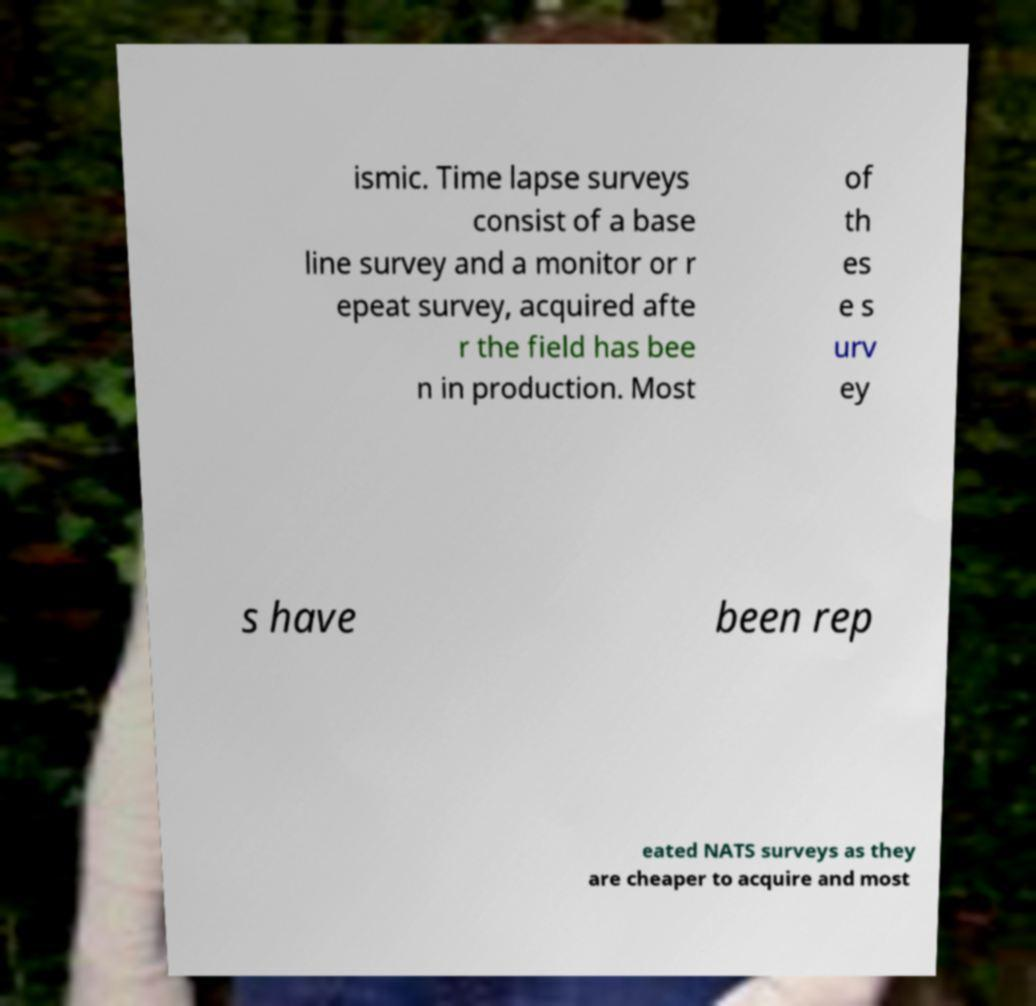What messages or text are displayed in this image? I need them in a readable, typed format. ismic. Time lapse surveys consist of a base line survey and a monitor or r epeat survey, acquired afte r the field has bee n in production. Most of th es e s urv ey s have been rep eated NATS surveys as they are cheaper to acquire and most 